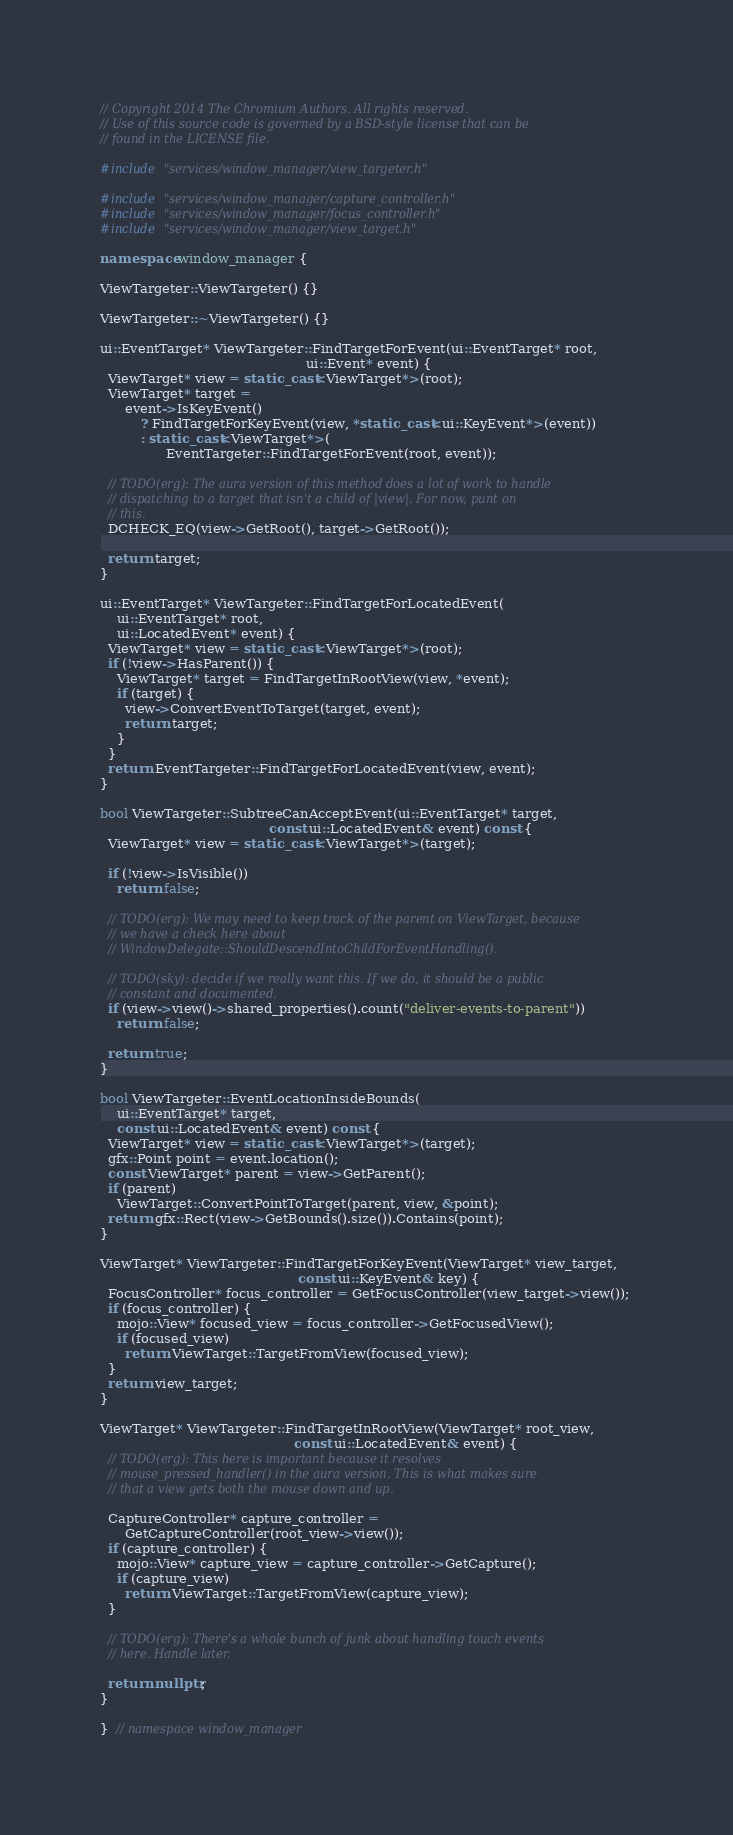Convert code to text. <code><loc_0><loc_0><loc_500><loc_500><_C++_>// Copyright 2014 The Chromium Authors. All rights reserved.
// Use of this source code is governed by a BSD-style license that can be
// found in the LICENSE file.

#include "services/window_manager/view_targeter.h"

#include "services/window_manager/capture_controller.h"
#include "services/window_manager/focus_controller.h"
#include "services/window_manager/view_target.h"

namespace window_manager {

ViewTargeter::ViewTargeter() {}

ViewTargeter::~ViewTargeter() {}

ui::EventTarget* ViewTargeter::FindTargetForEvent(ui::EventTarget* root,
                                                  ui::Event* event) {
  ViewTarget* view = static_cast<ViewTarget*>(root);
  ViewTarget* target =
      event->IsKeyEvent()
          ? FindTargetForKeyEvent(view, *static_cast<ui::KeyEvent*>(event))
          : static_cast<ViewTarget*>(
                EventTargeter::FindTargetForEvent(root, event));

  // TODO(erg): The aura version of this method does a lot of work to handle
  // dispatching to a target that isn't a child of |view|. For now, punt on
  // this.
  DCHECK_EQ(view->GetRoot(), target->GetRoot());

  return target;
}

ui::EventTarget* ViewTargeter::FindTargetForLocatedEvent(
    ui::EventTarget* root,
    ui::LocatedEvent* event) {
  ViewTarget* view = static_cast<ViewTarget*>(root);
  if (!view->HasParent()) {
    ViewTarget* target = FindTargetInRootView(view, *event);
    if (target) {
      view->ConvertEventToTarget(target, event);
      return target;
    }
  }
  return EventTargeter::FindTargetForLocatedEvent(view, event);
}

bool ViewTargeter::SubtreeCanAcceptEvent(ui::EventTarget* target,
                                         const ui::LocatedEvent& event) const {
  ViewTarget* view = static_cast<ViewTarget*>(target);

  if (!view->IsVisible())
    return false;

  // TODO(erg): We may need to keep track of the parent on ViewTarget, because
  // we have a check here about
  // WindowDelegate::ShouldDescendIntoChildForEventHandling().

  // TODO(sky): decide if we really want this. If we do, it should be a public
  // constant and documented.
  if (view->view()->shared_properties().count("deliver-events-to-parent"))
    return false;

  return true;
}

bool ViewTargeter::EventLocationInsideBounds(
    ui::EventTarget* target,
    const ui::LocatedEvent& event) const {
  ViewTarget* view = static_cast<ViewTarget*>(target);
  gfx::Point point = event.location();
  const ViewTarget* parent = view->GetParent();
  if (parent)
    ViewTarget::ConvertPointToTarget(parent, view, &point);
  return gfx::Rect(view->GetBounds().size()).Contains(point);
}

ViewTarget* ViewTargeter::FindTargetForKeyEvent(ViewTarget* view_target,
                                                const ui::KeyEvent& key) {
  FocusController* focus_controller = GetFocusController(view_target->view());
  if (focus_controller) {
    mojo::View* focused_view = focus_controller->GetFocusedView();
    if (focused_view)
      return ViewTarget::TargetFromView(focused_view);
  }
  return view_target;
}

ViewTarget* ViewTargeter::FindTargetInRootView(ViewTarget* root_view,
                                               const ui::LocatedEvent& event) {
  // TODO(erg): This here is important because it resolves
  // mouse_pressed_handler() in the aura version. This is what makes sure
  // that a view gets both the mouse down and up.

  CaptureController* capture_controller =
      GetCaptureController(root_view->view());
  if (capture_controller) {
    mojo::View* capture_view = capture_controller->GetCapture();
    if (capture_view)
      return ViewTarget::TargetFromView(capture_view);
  }

  // TODO(erg): There's a whole bunch of junk about handling touch events
  // here. Handle later.

  return nullptr;
}

}  // namespace window_manager
</code> 